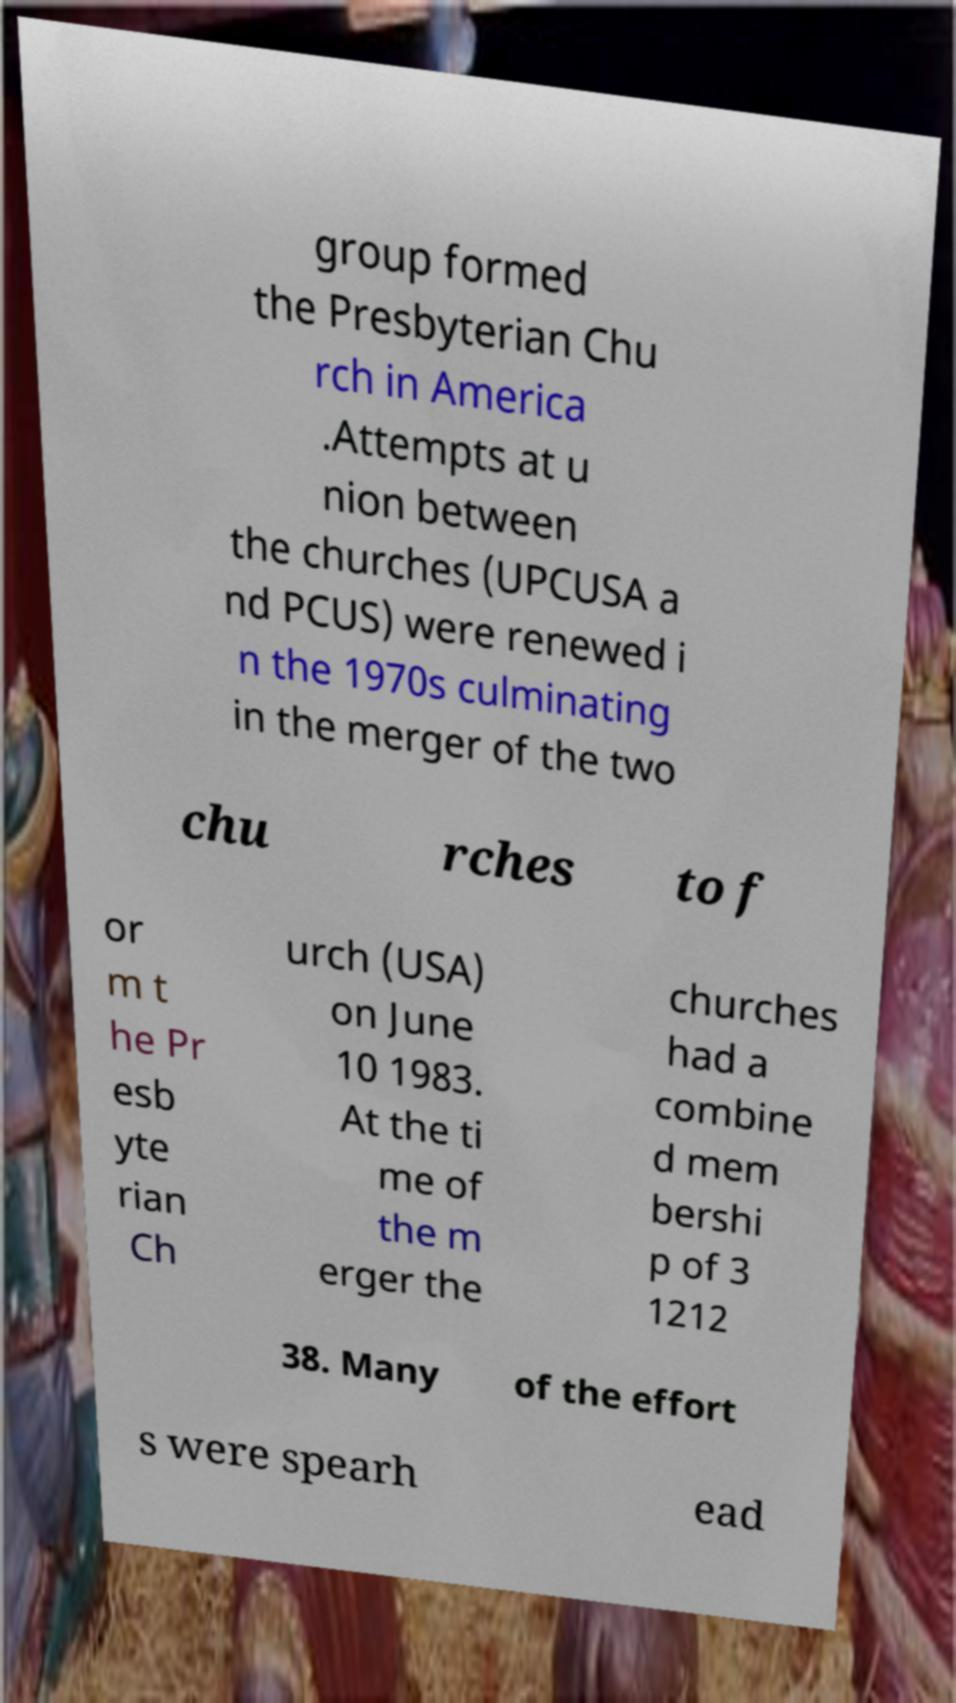Could you extract and type out the text from this image? group formed the Presbyterian Chu rch in America .Attempts at u nion between the churches (UPCUSA a nd PCUS) were renewed i n the 1970s culminating in the merger of the two chu rches to f or m t he Pr esb yte rian Ch urch (USA) on June 10 1983. At the ti me of the m erger the churches had a combine d mem bershi p of 3 1212 38. Many of the effort s were spearh ead 